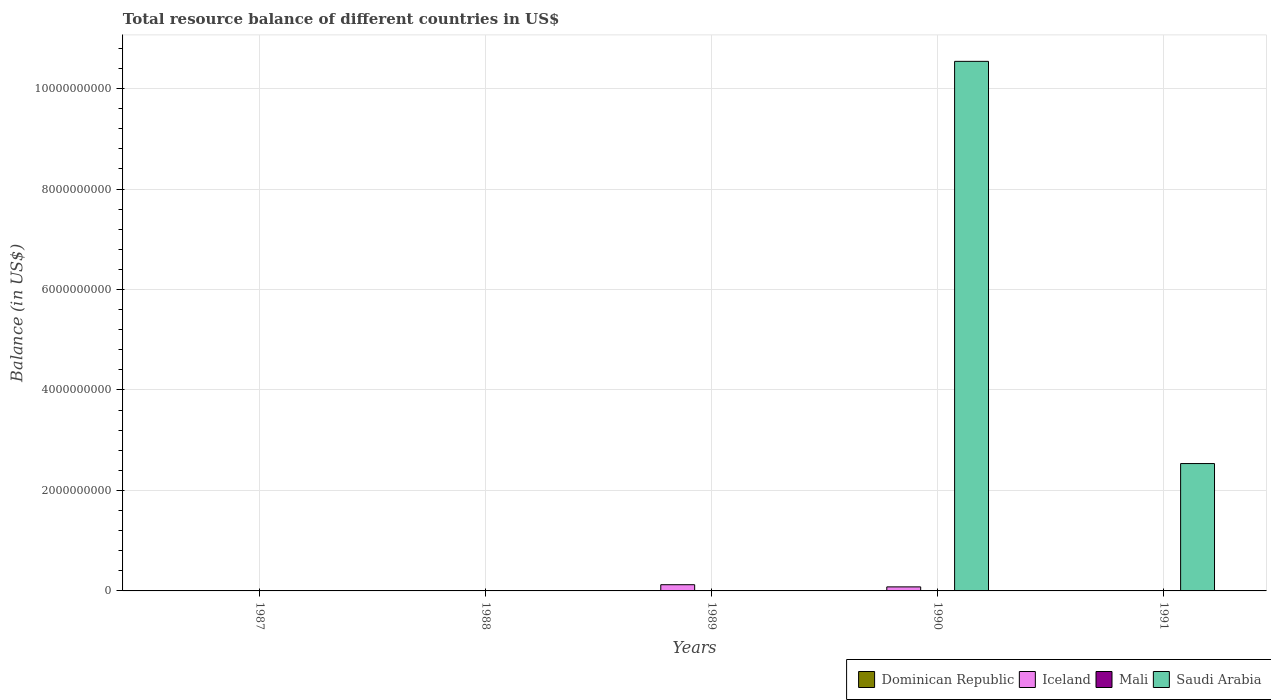Are the number of bars per tick equal to the number of legend labels?
Your answer should be very brief. No. Are the number of bars on each tick of the X-axis equal?
Provide a short and direct response. No. How many bars are there on the 3rd tick from the left?
Keep it short and to the point. 1. What is the label of the 2nd group of bars from the left?
Make the answer very short. 1988. Across all years, what is the maximum total resource balance in Saudi Arabia?
Offer a terse response. 1.05e+1. What is the difference between the total resource balance in Iceland in 1989 and that in 1990?
Provide a succinct answer. 4.31e+07. What is the difference between the total resource balance in Dominican Republic in 1987 and the total resource balance in Iceland in 1991?
Provide a succinct answer. 0. What is the average total resource balance in Iceland per year?
Your response must be concise. 4.08e+07. What is the ratio of the total resource balance in Saudi Arabia in 1990 to that in 1991?
Provide a short and direct response. 4.16. What is the difference between the highest and the lowest total resource balance in Saudi Arabia?
Ensure brevity in your answer.  1.05e+1. In how many years, is the total resource balance in Mali greater than the average total resource balance in Mali taken over all years?
Offer a very short reply. 0. Are all the bars in the graph horizontal?
Your answer should be very brief. No. What is the difference between two consecutive major ticks on the Y-axis?
Give a very brief answer. 2.00e+09. Are the values on the major ticks of Y-axis written in scientific E-notation?
Keep it short and to the point. No. Does the graph contain grids?
Keep it short and to the point. Yes. Where does the legend appear in the graph?
Offer a terse response. Bottom right. How many legend labels are there?
Your response must be concise. 4. How are the legend labels stacked?
Provide a short and direct response. Horizontal. What is the title of the graph?
Offer a very short reply. Total resource balance of different countries in US$. What is the label or title of the X-axis?
Provide a short and direct response. Years. What is the label or title of the Y-axis?
Offer a terse response. Balance (in US$). What is the Balance (in US$) of Dominican Republic in 1987?
Provide a short and direct response. 0. What is the Balance (in US$) of Saudi Arabia in 1987?
Offer a terse response. 0. What is the Balance (in US$) of Dominican Republic in 1988?
Ensure brevity in your answer.  0. What is the Balance (in US$) of Mali in 1988?
Offer a terse response. 0. What is the Balance (in US$) in Dominican Republic in 1989?
Provide a succinct answer. 0. What is the Balance (in US$) in Iceland in 1989?
Give a very brief answer. 1.24e+08. What is the Balance (in US$) in Dominican Republic in 1990?
Give a very brief answer. 0. What is the Balance (in US$) in Iceland in 1990?
Give a very brief answer. 8.05e+07. What is the Balance (in US$) in Mali in 1990?
Provide a short and direct response. 0. What is the Balance (in US$) in Saudi Arabia in 1990?
Offer a terse response. 1.05e+1. What is the Balance (in US$) of Iceland in 1991?
Your answer should be very brief. 0. What is the Balance (in US$) of Mali in 1991?
Make the answer very short. 0. What is the Balance (in US$) in Saudi Arabia in 1991?
Offer a very short reply. 2.54e+09. Across all years, what is the maximum Balance (in US$) in Iceland?
Offer a very short reply. 1.24e+08. Across all years, what is the maximum Balance (in US$) of Saudi Arabia?
Offer a terse response. 1.05e+1. What is the total Balance (in US$) of Iceland in the graph?
Your answer should be very brief. 2.04e+08. What is the total Balance (in US$) of Mali in the graph?
Offer a terse response. 0. What is the total Balance (in US$) in Saudi Arabia in the graph?
Your response must be concise. 1.31e+1. What is the difference between the Balance (in US$) of Iceland in 1989 and that in 1990?
Give a very brief answer. 4.31e+07. What is the difference between the Balance (in US$) of Saudi Arabia in 1990 and that in 1991?
Provide a short and direct response. 8.01e+09. What is the difference between the Balance (in US$) of Iceland in 1989 and the Balance (in US$) of Saudi Arabia in 1990?
Your answer should be very brief. -1.04e+1. What is the difference between the Balance (in US$) of Iceland in 1989 and the Balance (in US$) of Saudi Arabia in 1991?
Your answer should be very brief. -2.41e+09. What is the difference between the Balance (in US$) in Iceland in 1990 and the Balance (in US$) in Saudi Arabia in 1991?
Keep it short and to the point. -2.45e+09. What is the average Balance (in US$) of Dominican Republic per year?
Provide a succinct answer. 0. What is the average Balance (in US$) in Iceland per year?
Provide a succinct answer. 4.08e+07. What is the average Balance (in US$) in Mali per year?
Offer a terse response. 0. What is the average Balance (in US$) of Saudi Arabia per year?
Your answer should be very brief. 2.62e+09. In the year 1990, what is the difference between the Balance (in US$) of Iceland and Balance (in US$) of Saudi Arabia?
Offer a very short reply. -1.05e+1. What is the ratio of the Balance (in US$) of Iceland in 1989 to that in 1990?
Offer a terse response. 1.54. What is the ratio of the Balance (in US$) in Saudi Arabia in 1990 to that in 1991?
Ensure brevity in your answer.  4.16. What is the difference between the highest and the lowest Balance (in US$) of Iceland?
Make the answer very short. 1.24e+08. What is the difference between the highest and the lowest Balance (in US$) in Saudi Arabia?
Your answer should be compact. 1.05e+1. 